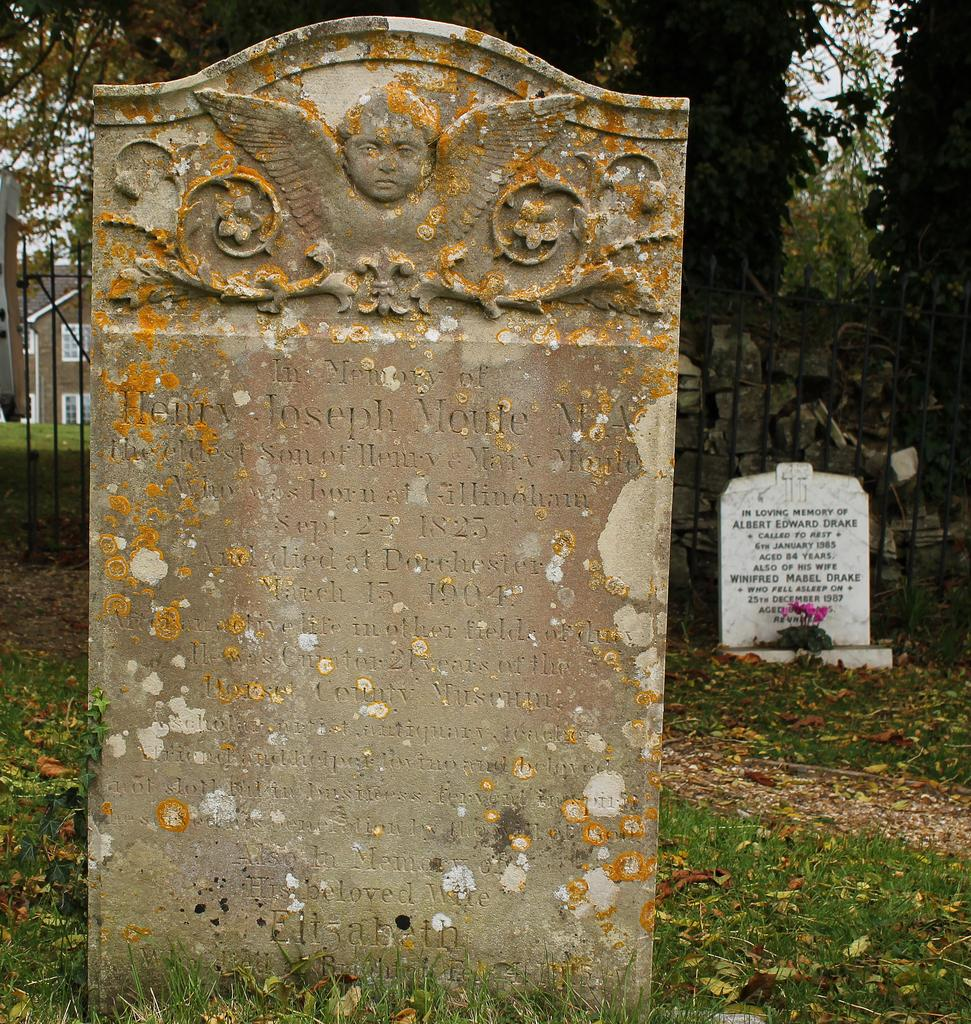What type of objects are on the ground in the image? There are graveyard stones on the ground in the image. What can be seen on the left side of the image? There are grills on the left side of the image. What is present on the right side of the image? There are also grills on the right side of the image. What type of vegetation is visible in the top right corner of the image? There are trees in the top right corner of the image. What type of battle is taking place in the image? There is no battle present in the image; it features graveyard stones, grills, and trees. What type of harmony is depicted in the image? The image does not depict any specific harmony; it simply shows graveyard stones, grills, and trees. 